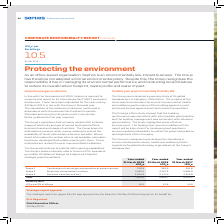According to Sophos Group's financial document, What does the Companies Act 2006 require Sophos to do? Sophos is required to measure and report on its Greenhouse Gas (“GHG”) emissions disclosures.. The document states: "In line with the Companies Act 2006, Sophos is required to measure and report on its Greenhouse Gas (“GHG”) emissions disclosures. These have been cal..." Also, What does the Group's operations that primarily release GHG include? usage of electricity and gas of owned and leased offices, business travel and usage of vehicles.. The document states: "p’s operations that primarily release GHG includes usage of electricity and gas of owned and leased offices, business travel and usage of vehicles. Th..." Also, What are the scopes considered in the table when calculating the total greenhouse gas emissions? The document contains multiple relevant values: Combustion of natural gas and operation of owned vehicles, Electricity consumption in offices, Business travel (air and car). From the document: "Scope 3 Business travel (air and car) 3,260.9 5,117.4 4,510.9 Scope 2 Electricity consumption in offices 4,487.2 4,457.3 4,681.9 Scope 1 Combustion of..." Additionally, In which year was the total Greenhouse gas emissions the largest? According to the financial document, 2018. The relevant text states: "Year-ended 31 March 2018 tCO 2 e..." Also, can you calculate: What was the change in the intensity ratio in 2019 from 2018? Based on the calculation: 10.5-12.9, the result is -2.4. This is based on the information: "tCO 2 e per $m billings 10.5 (FY18: 12.9)..." The key data points involved are: 10.5, 12.9. Also, can you calculate: What was the percentage change in the intensity ratio in 2019 from 2018? To answer this question, I need to perform calculations using the financial data. The calculation is: (10.5-12.9)/12.9, which equals -18.6 (percentage). This is based on the information: "tCO 2 e per $m billings 10.5 (FY18: 12.9)..." The key data points involved are: 10.5, 12.9. 